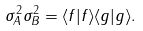Convert formula to latex. <formula><loc_0><loc_0><loc_500><loc_500>\sigma _ { A } ^ { 2 } \sigma _ { B } ^ { 2 } = \langle f | f \rangle \langle g | g \rangle .</formula> 